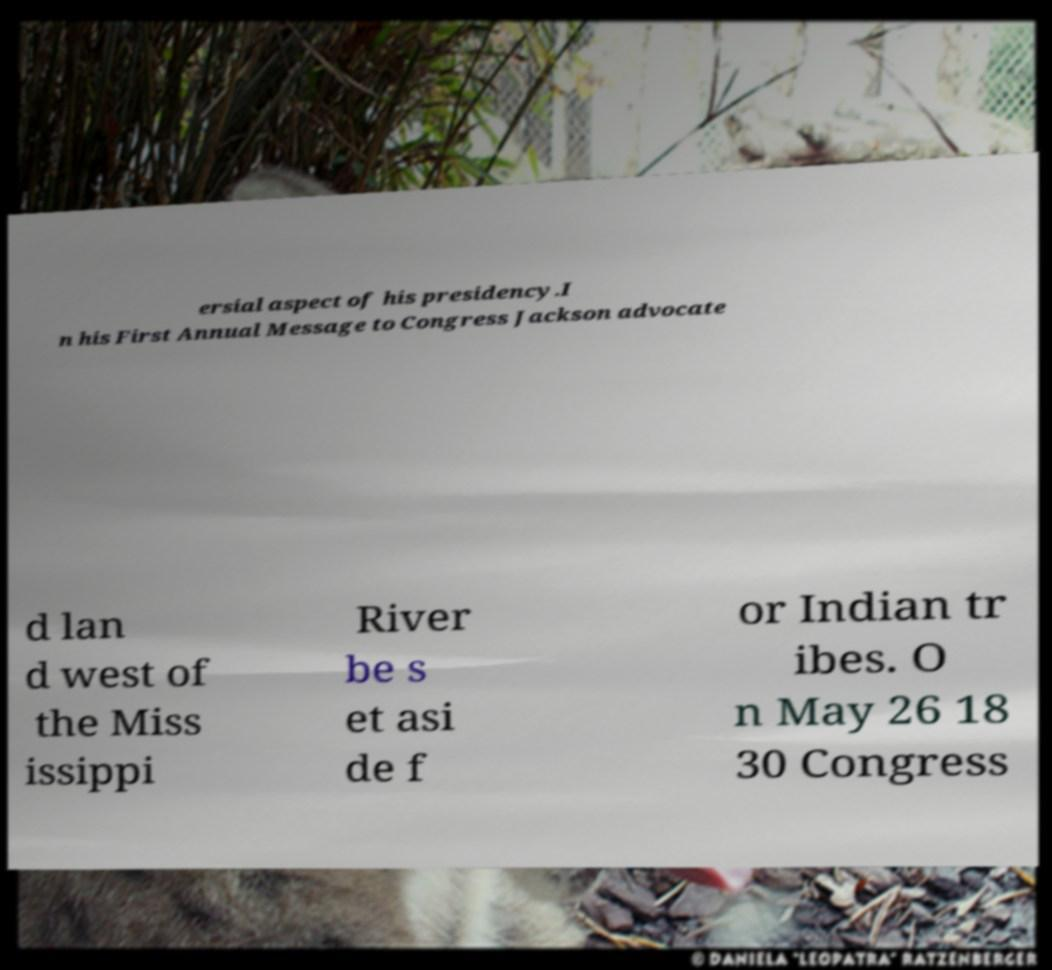Please read and relay the text visible in this image. What does it say? ersial aspect of his presidency.I n his First Annual Message to Congress Jackson advocate d lan d west of the Miss issippi River be s et asi de f or Indian tr ibes. O n May 26 18 30 Congress 